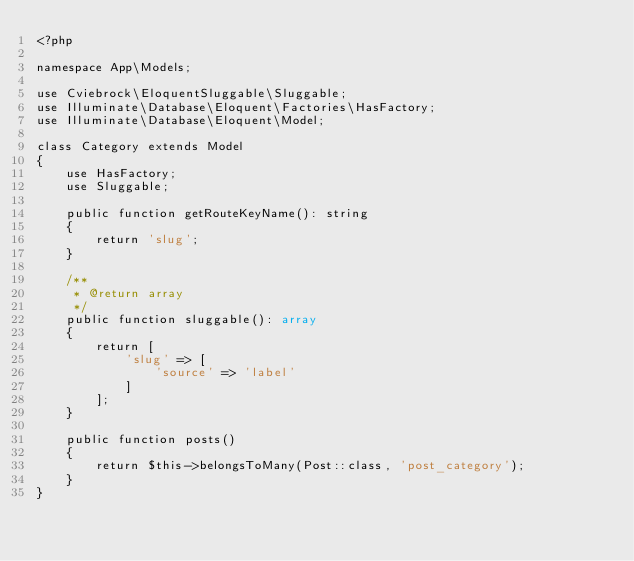Convert code to text. <code><loc_0><loc_0><loc_500><loc_500><_PHP_><?php

namespace App\Models;

use Cviebrock\EloquentSluggable\Sluggable;
use Illuminate\Database\Eloquent\Factories\HasFactory;
use Illuminate\Database\Eloquent\Model;

class Category extends Model
{
    use HasFactory;
    use Sluggable;

    public function getRouteKeyName(): string
    {
        return 'slug';
    }

    /**
     * @return array
     */
    public function sluggable(): array
    {
        return [
            'slug' => [
                'source' => 'label'
            ]
        ];
    }

    public function posts()
    {
        return $this->belongsToMany(Post::class, 'post_category');
    }
}
</code> 